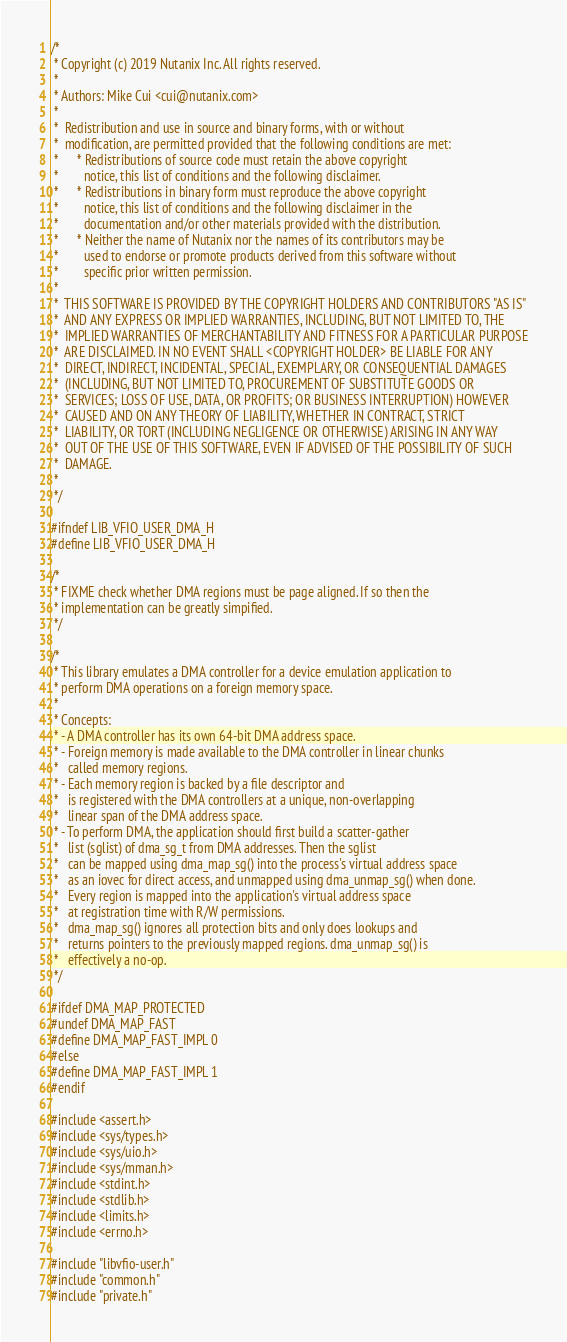<code> <loc_0><loc_0><loc_500><loc_500><_C_>/*
 * Copyright (c) 2019 Nutanix Inc. All rights reserved.
 *
 * Authors: Mike Cui <cui@nutanix.com>
 *
 *  Redistribution and use in source and binary forms, with or without
 *  modification, are permitted provided that the following conditions are met:
 *      * Redistributions of source code must retain the above copyright
 *        notice, this list of conditions and the following disclaimer.
 *      * Redistributions in binary form must reproduce the above copyright
 *        notice, this list of conditions and the following disclaimer in the
 *        documentation and/or other materials provided with the distribution.
 *      * Neither the name of Nutanix nor the names of its contributors may be
 *        used to endorse or promote products derived from this software without
 *        specific prior written permission.
 *
 *  THIS SOFTWARE IS PROVIDED BY THE COPYRIGHT HOLDERS AND CONTRIBUTORS "AS IS"
 *  AND ANY EXPRESS OR IMPLIED WARRANTIES, INCLUDING, BUT NOT LIMITED TO, THE
 *  IMPLIED WARRANTIES OF MERCHANTABILITY AND FITNESS FOR A PARTICULAR PURPOSE
 *  ARE DISCLAIMED. IN NO EVENT SHALL <COPYRIGHT HOLDER> BE LIABLE FOR ANY
 *  DIRECT, INDIRECT, INCIDENTAL, SPECIAL, EXEMPLARY, OR CONSEQUENTIAL DAMAGES
 *  (INCLUDING, BUT NOT LIMITED TO, PROCUREMENT OF SUBSTITUTE GOODS OR
 *  SERVICES; LOSS OF USE, DATA, OR PROFITS; OR BUSINESS INTERRUPTION) HOWEVER
 *  CAUSED AND ON ANY THEORY OF LIABILITY, WHETHER IN CONTRACT, STRICT
 *  LIABILITY, OR TORT (INCLUDING NEGLIGENCE OR OTHERWISE) ARISING IN ANY WAY
 *  OUT OF THE USE OF THIS SOFTWARE, EVEN IF ADVISED OF THE POSSIBILITY OF SUCH
 *  DAMAGE.
 *
 */

#ifndef LIB_VFIO_USER_DMA_H
#define LIB_VFIO_USER_DMA_H

/*
 * FIXME check whether DMA regions must be page aligned. If so then the
 * implementation can be greatly simpified.
 */

/*
 * This library emulates a DMA controller for a device emulation application to
 * perform DMA operations on a foreign memory space.
 *
 * Concepts:
 * - A DMA controller has its own 64-bit DMA address space.
 * - Foreign memory is made available to the DMA controller in linear chunks
 *   called memory regions.
 * - Each memory region is backed by a file descriptor and
 *   is registered with the DMA controllers at a unique, non-overlapping
 *   linear span of the DMA address space.
 * - To perform DMA, the application should first build a scatter-gather
 *   list (sglist) of dma_sg_t from DMA addresses. Then the sglist
 *   can be mapped using dma_map_sg() into the process's virtual address space
 *   as an iovec for direct access, and unmapped using dma_unmap_sg() when done.
 *   Every region is mapped into the application's virtual address space
 *   at registration time with R/W permissions.
 *   dma_map_sg() ignores all protection bits and only does lookups and
 *   returns pointers to the previously mapped regions. dma_unmap_sg() is
 *   effectively a no-op.
 */

#ifdef DMA_MAP_PROTECTED
#undef DMA_MAP_FAST
#define DMA_MAP_FAST_IMPL 0
#else
#define DMA_MAP_FAST_IMPL 1
#endif

#include <assert.h>
#include <sys/types.h>
#include <sys/uio.h>
#include <sys/mman.h>
#include <stdint.h>
#include <stdlib.h>
#include <limits.h>
#include <errno.h>

#include "libvfio-user.h"
#include "common.h"
#include "private.h"
</code> 